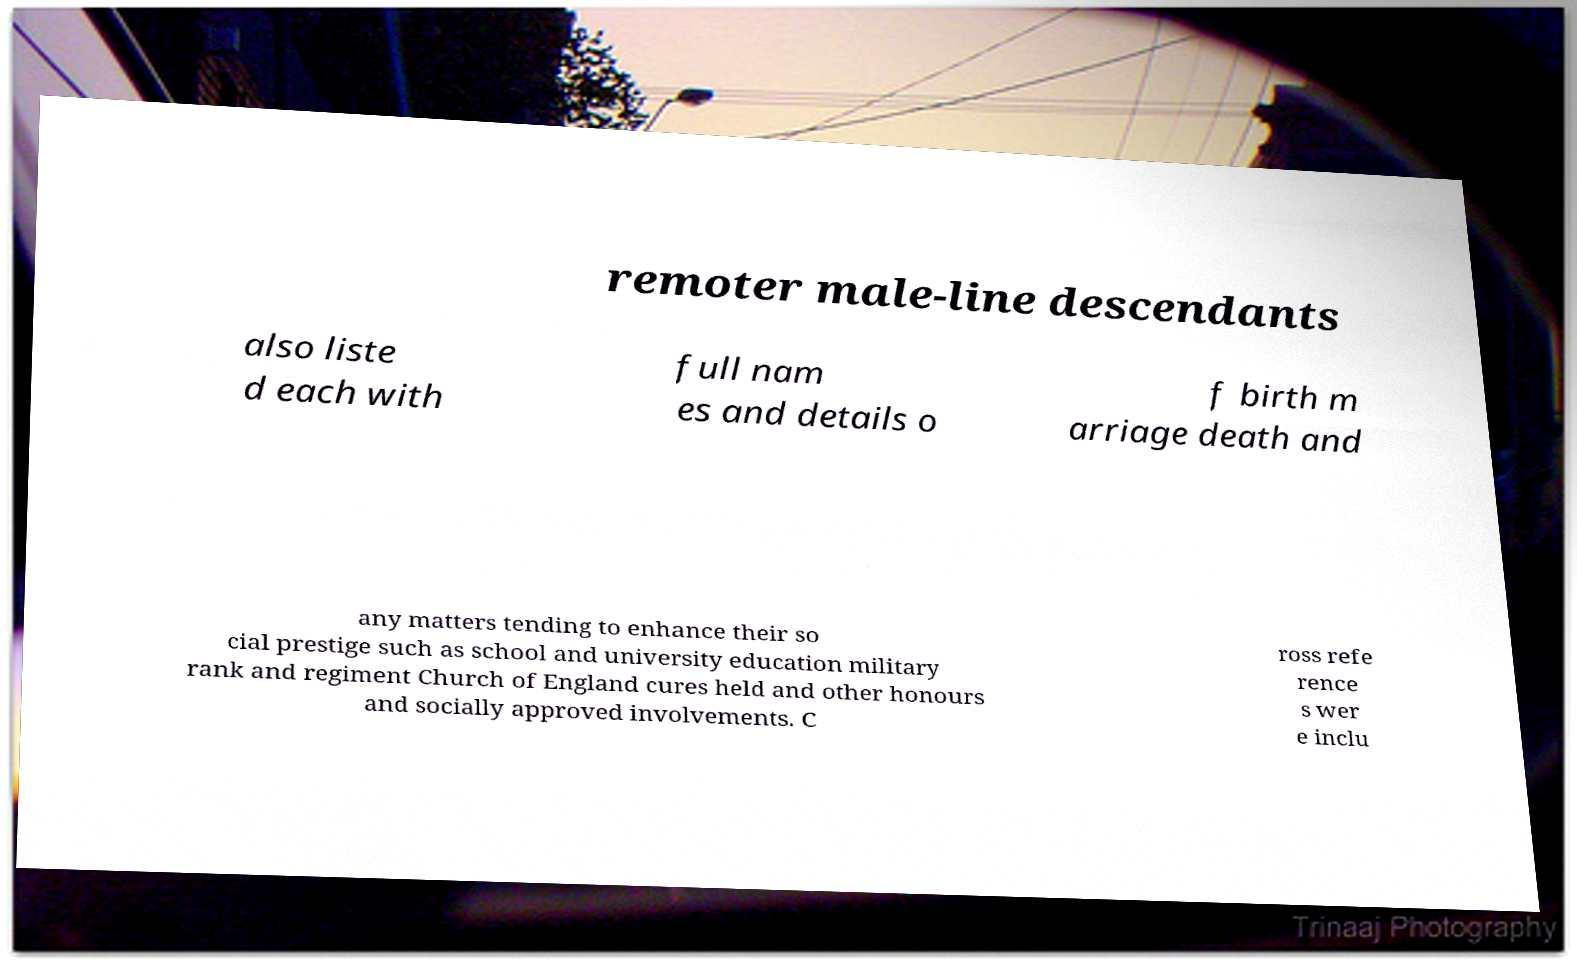Please read and relay the text visible in this image. What does it say? remoter male-line descendants also liste d each with full nam es and details o f birth m arriage death and any matters tending to enhance their so cial prestige such as school and university education military rank and regiment Church of England cures held and other honours and socially approved involvements. C ross refe rence s wer e inclu 